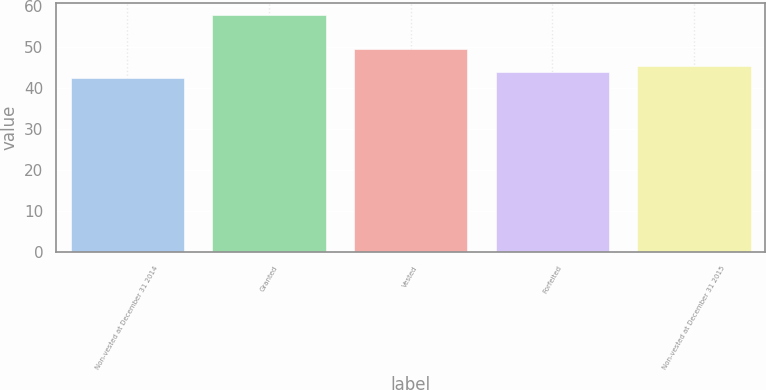<chart> <loc_0><loc_0><loc_500><loc_500><bar_chart><fcel>Non-vested at December 31 2014<fcel>Granted<fcel>Vested<fcel>Forfeited<fcel>Non-vested at December 31 2015<nl><fcel>42.33<fcel>57.67<fcel>49.45<fcel>43.86<fcel>45.39<nl></chart> 